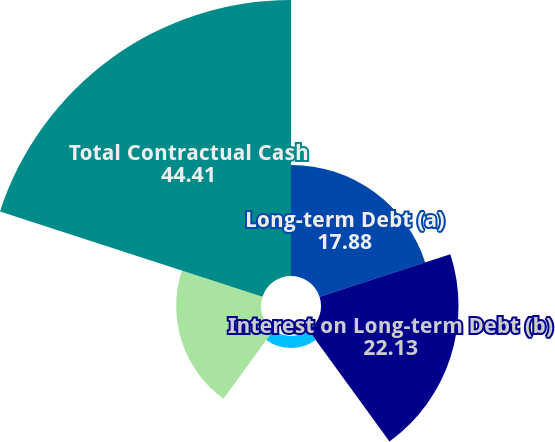Convert chart. <chart><loc_0><loc_0><loc_500><loc_500><pie_chart><fcel>Long-term Debt (a)<fcel>Interest on Long-term Debt (b)<fcel>Operating Leases<fcel>Purchase Obligations (c)<fcel>Total Contractual Cash<nl><fcel>17.88%<fcel>22.13%<fcel>1.94%<fcel>13.64%<fcel>44.41%<nl></chart> 